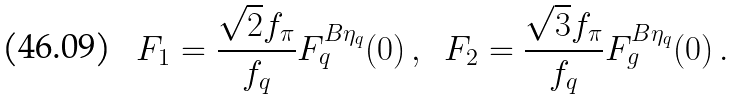Convert formula to latex. <formula><loc_0><loc_0><loc_500><loc_500>F _ { 1 } = \frac { \sqrt { 2 } f _ { \pi } } { f _ { q } } F _ { q } ^ { B \eta _ { q } } ( 0 ) \, , \ \ F _ { 2 } = \frac { \sqrt { 3 } f _ { \pi } } { f _ { q } } F _ { g } ^ { B \eta _ { q } } ( 0 ) \, .</formula> 